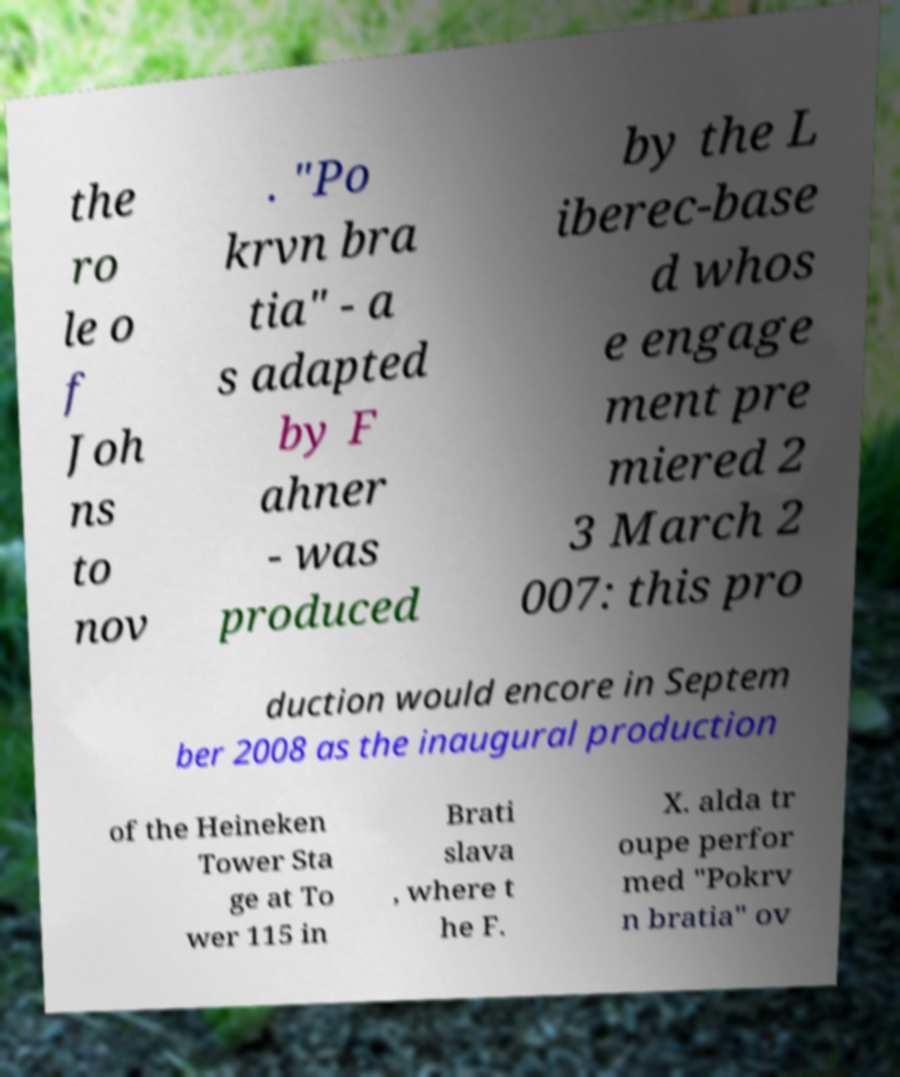Could you assist in decoding the text presented in this image and type it out clearly? the ro le o f Joh ns to nov . "Po krvn bra tia" - a s adapted by F ahner - was produced by the L iberec-base d whos e engage ment pre miered 2 3 March 2 007: this pro duction would encore in Septem ber 2008 as the inaugural production of the Heineken Tower Sta ge at To wer 115 in Brati slava , where t he F. X. alda tr oupe perfor med "Pokrv n bratia" ov 